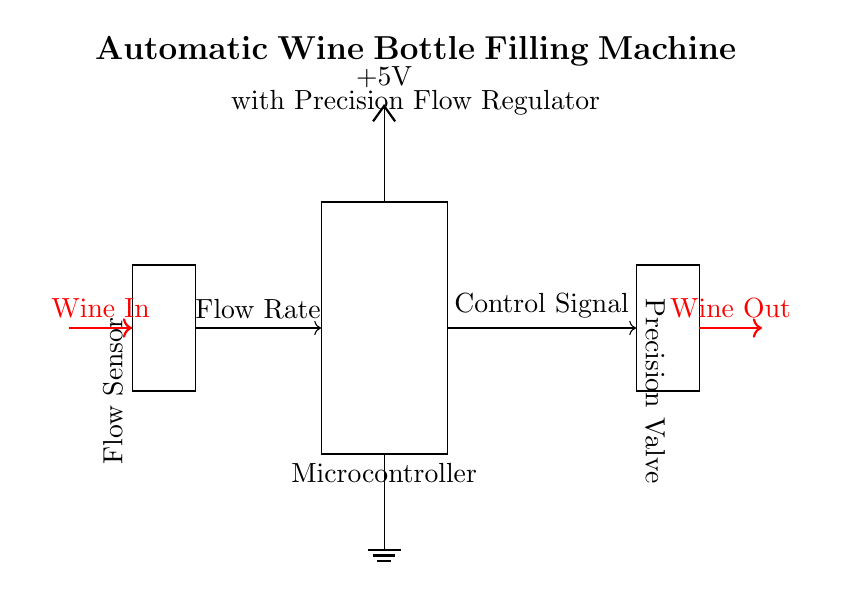What is the output component of this circuit? The output component is the Precision Valve, which is responsible for controlling the flow of wine out of the system.
Answer: Precision Valve What type of sensor is used in this circuit? The circuit utilizes a Flow Sensor, which measures the flow rate of wine in the system.
Answer: Flow Sensor What voltage does the microcontroller need to operate? The microcontroller operates at a voltage of five volts, as indicated in the power supply section of the circuit.
Answer: Five volts What is the function of the microcontroller in this circuit? The microcontroller processes the flow rate data from the Flow Sensor and sends control signals to the Precision Valve to regulate wine flow accurately.
Answer: Control How does the flow sensor interact with the microcontroller? The Flow Sensor measures the flow rate and sends this data to the microcontroller via a control signal, which allows for precise regulation of the wine filling process.
Answer: Flow rate data What is the direction of wine flow in this circuit? Wine flows into the circuit from the left side entering at the position labeled Wine In and exits from the right at the position labeled Wine Out, indicating a clear direction of flow through the system.
Answer: In to Out 